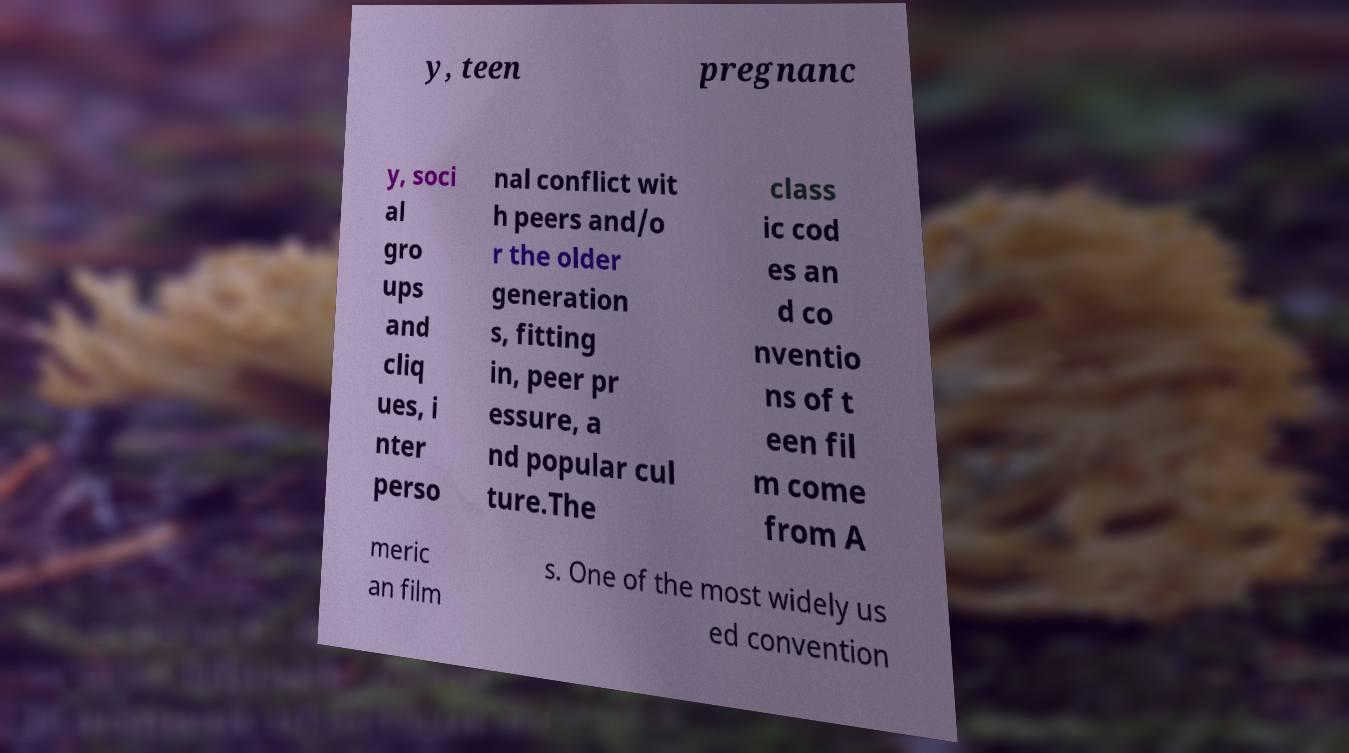Please read and relay the text visible in this image. What does it say? y, teen pregnanc y, soci al gro ups and cliq ues, i nter perso nal conflict wit h peers and/o r the older generation s, fitting in, peer pr essure, a nd popular cul ture.The class ic cod es an d co nventio ns of t een fil m come from A meric an film s. One of the most widely us ed convention 